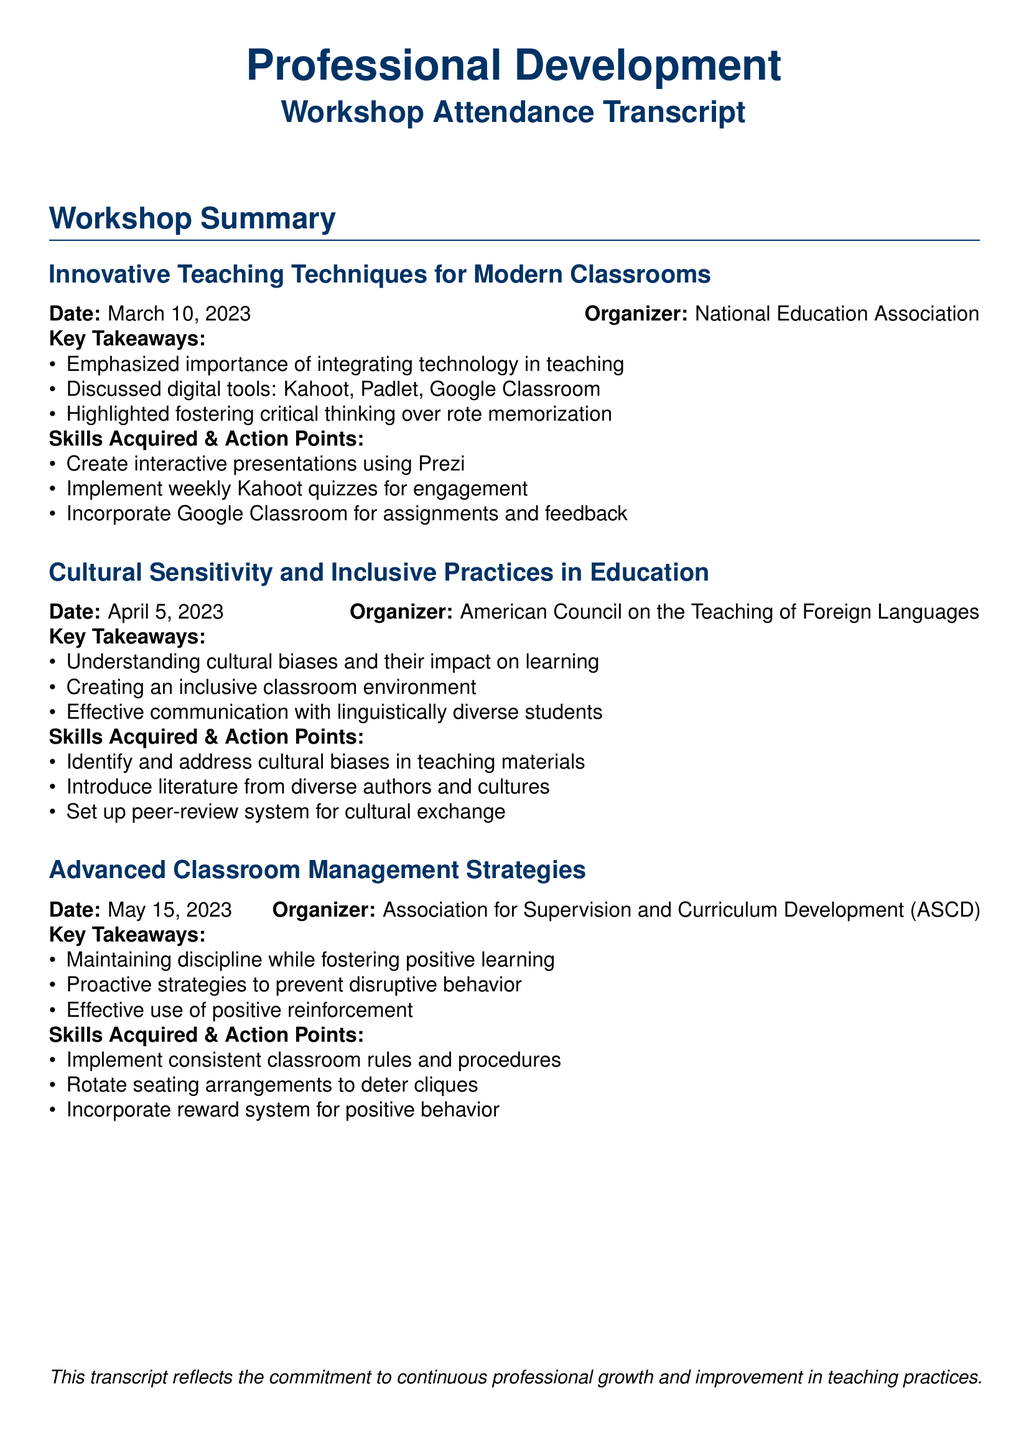What is the date of the workshop on innovative teaching techniques? The date is specifically mentioned in the section about the workshop titled "Innovative Teaching Techniques for Modern Classrooms."
Answer: March 10, 2023 Who organized the workshop on cultural sensitivity? The organizer is listed next to the workshop title "Cultural Sensitivity and Inclusive Practices in Education."
Answer: American Council on the Teaching of Foreign Languages What is one digital tool highlighted in the first workshop? The document lists digital tools under the key takeaways of the first workshop, which discusses their importance in teaching.
Answer: Kahoot What is a key takeaway from the workshop on advanced classroom management strategies? One of the key takeaways is provided under the summary of the relevant workshop section.
Answer: Maintaining discipline while fostering positive learning What action point is suggested for improving cultural sensitivity in materials? The action points are related solutions to the takeaways mentioned in the cultural sensitivity workshop.
Answer: Identify and address cultural biases in teaching materials What was emphasized in the innovative teaching techniques workshop? The emphasis is stated clearly in the key takeaways section of that workshop.
Answer: Integrating technology in teaching How many workshops are summarized in the document? The total count of workshops discussed can be found by reviewing the sections labeled "workshop" in the document.
Answer: Three What is one skill acquired from the advanced classroom management strategies workshop? The skills acquired are detailed under the relevant workshop summary, specifying actionable skills from the session.
Answer: Implement consistent classroom rules and procedures 